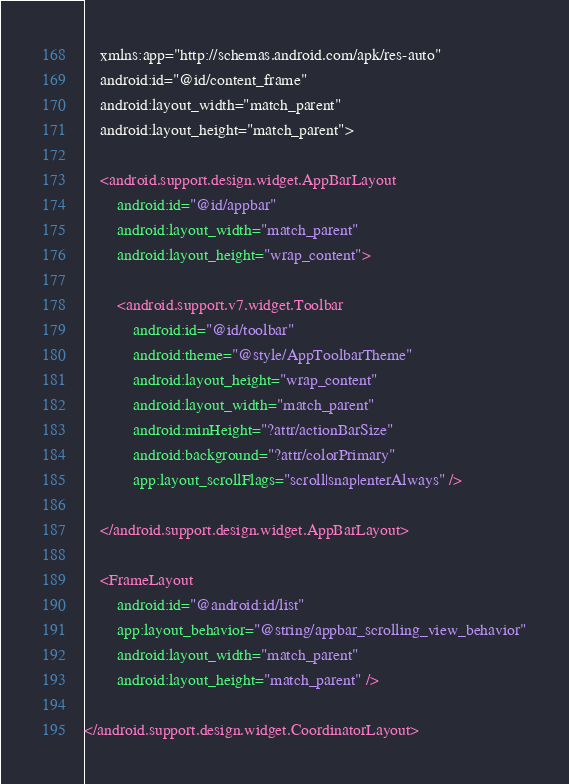<code> <loc_0><loc_0><loc_500><loc_500><_XML_>    xmlns:app="http://schemas.android.com/apk/res-auto"
    android:id="@id/content_frame"
    android:layout_width="match_parent"
    android:layout_height="match_parent">

    <android.support.design.widget.AppBarLayout
        android:id="@id/appbar"
        android:layout_width="match_parent"
        android:layout_height="wrap_content">

        <android.support.v7.widget.Toolbar
            android:id="@id/toolbar"
            android:theme="@style/AppToolbarTheme"
            android:layout_height="wrap_content"
            android:layout_width="match_parent"
            android:minHeight="?attr/actionBarSize"
            android:background="?attr/colorPrimary"
            app:layout_scrollFlags="scroll|snap|enterAlways" />

    </android.support.design.widget.AppBarLayout>

    <FrameLayout
        android:id="@android:id/list"
        app:layout_behavior="@string/appbar_scrolling_view_behavior"
        android:layout_width="match_parent"
        android:layout_height="match_parent" />

</android.support.design.widget.CoordinatorLayout>
</code> 